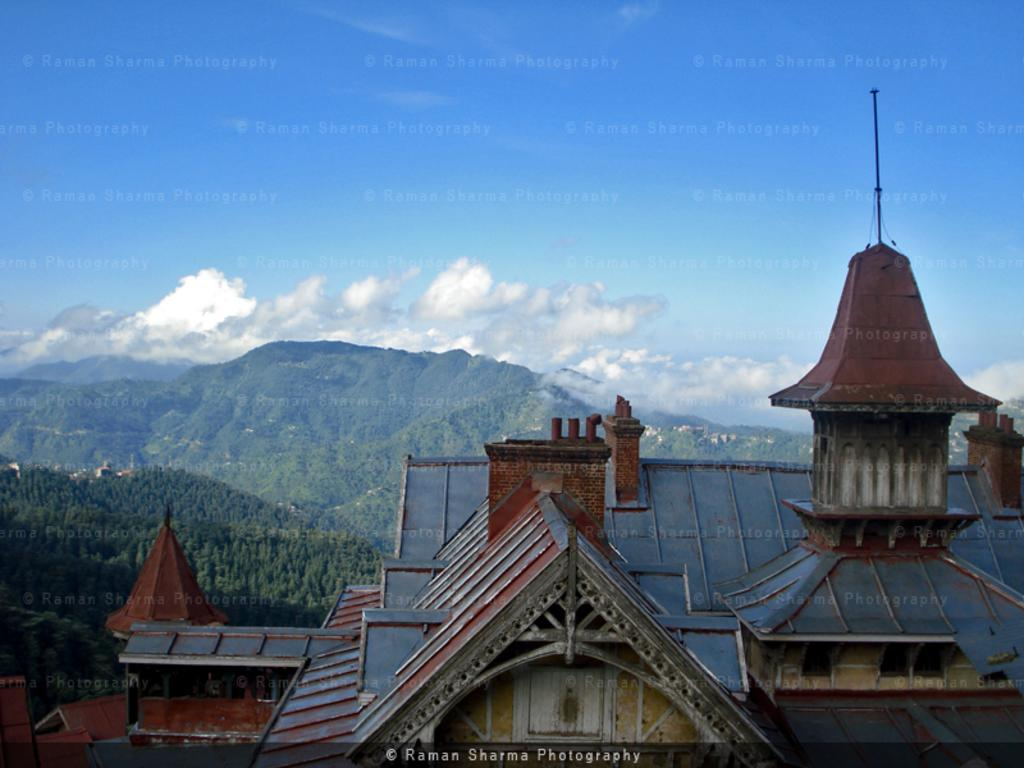What part of a house can be seen in the image? The roof of a house is visible in the image. What natural feature is present in the image? There is a mountain in the image. What type of vegetation is in the image? Trees are present in the image. What is visible in the background of the image? The sky is visible in the image. What type of imperfection can be seen on the image? Watermarks are observable in the image. Can you see a kitten playing on the roof in the image? There is no kitten present in the image. 